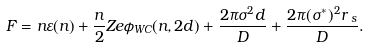Convert formula to latex. <formula><loc_0><loc_0><loc_500><loc_500>F = n \varepsilon ( n ) + \frac { n } { 2 } Z e \phi _ { W C } ( n , 2 d ) + \frac { 2 \pi \sigma ^ { 2 } d } { D } + \frac { 2 \pi ( \sigma ^ { * } ) ^ { 2 } r \, _ { s } } { D } .</formula> 